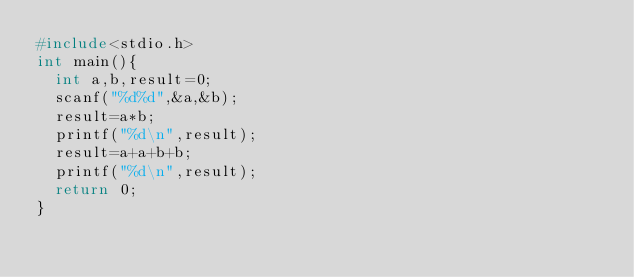Convert code to text. <code><loc_0><loc_0><loc_500><loc_500><_C_>#include<stdio.h>
int main(){
  int a,b,result=0;
  scanf("%d%d",&a,&b);
  result=a*b;
  printf("%d\n",result);
  result=a+a+b+b;
  printf("%d\n",result);
  return 0;
}

    </code> 